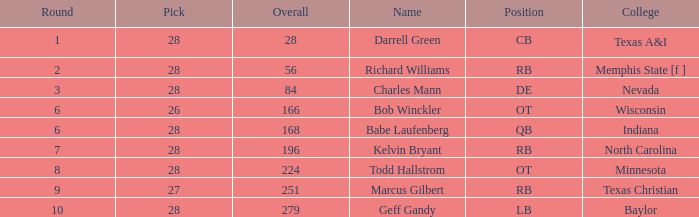What is the sum of the pick from texas a&i college with a round greater than 1? None. 